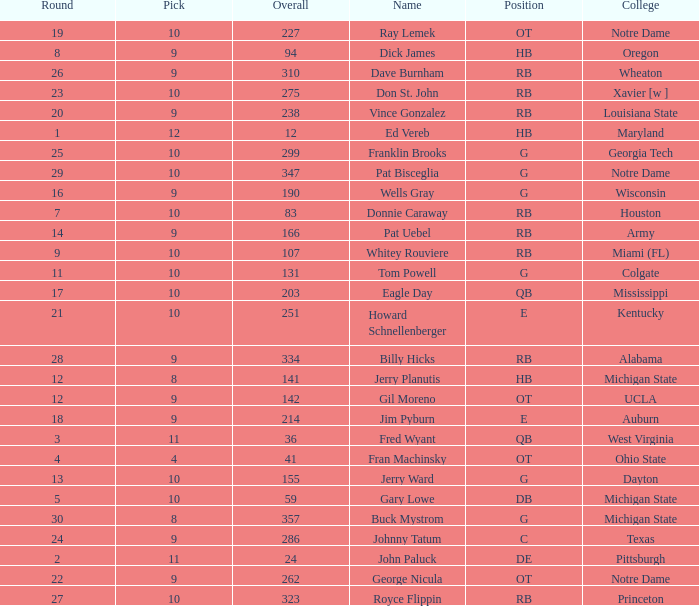What is the sum of rounds that has a pick of 9 and is named jim pyburn? 18.0. 